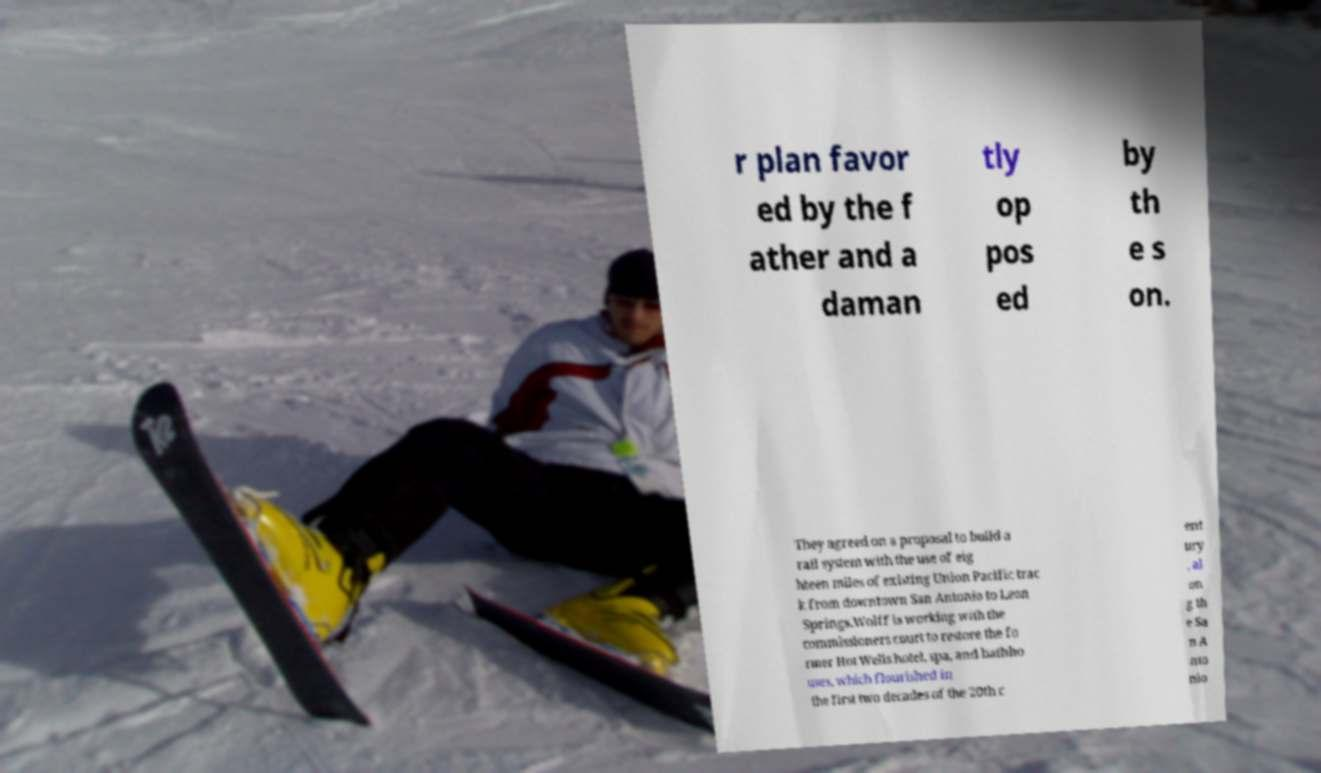Can you accurately transcribe the text from the provided image for me? r plan favor ed by the f ather and a daman tly op pos ed by th e s on. They agreed on a proposal to build a rail system with the use of eig hteen miles of existing Union Pacific trac k from downtown San Antonio to Leon Springs.Wolff is working with the commissioners court to restore the fo rmer Hot Wells hotel, spa, and bathho uses, which flourished in the first two decades of the 20th c ent ury , al on g th e Sa n A nto nio 